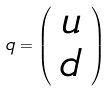Convert formula to latex. <formula><loc_0><loc_0><loc_500><loc_500>q = \left ( \begin{array} { c } u \\ d \end{array} \right )</formula> 